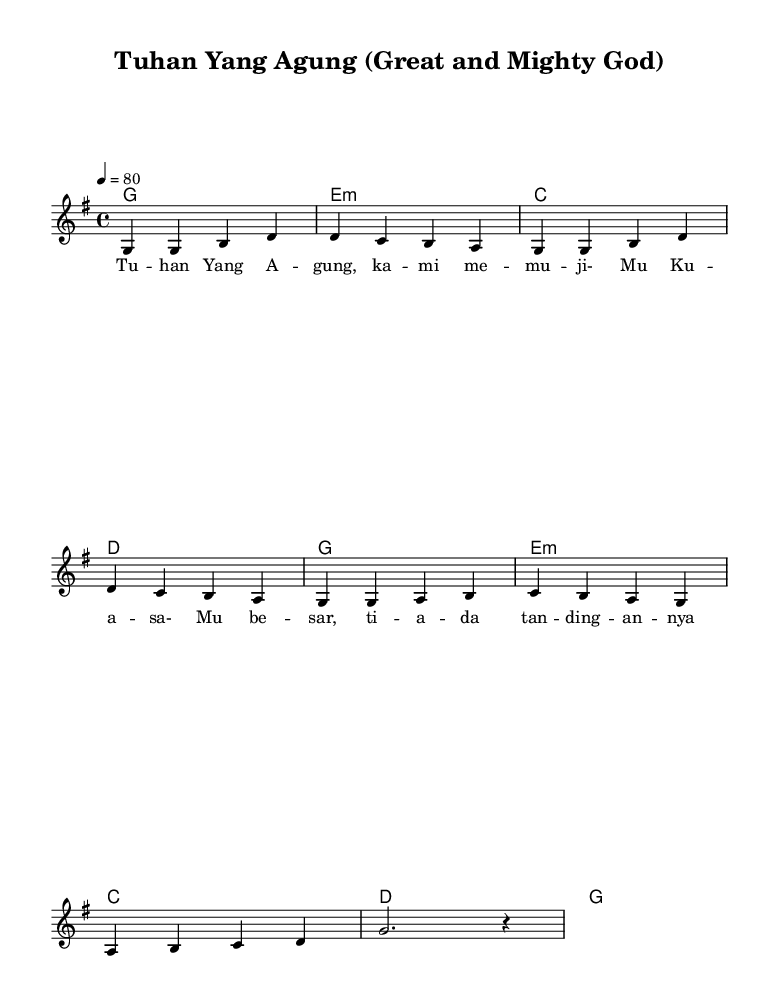What is the key signature of this music? The key signature is G major, which has one sharp (F#), identifiable by looking at the beginning of the staff.
Answer: G major What is the time signature of the piece? The time signature is 4/4, indicated at the beginning of the score. This means there are four beats in each measure.
Answer: 4/4 What is the tempo marking for the music? The tempo marking indicates a speed of 80 beats per minute, as seen at the beginning of the score.
Answer: 80 How many measures are in the melody? The melody consists of eight measures, which can be counted by looking at the bar lines that divide the music into segments.
Answer: 8 measures What is the tonic chord in this piece? The tonic chord is G major, as it is the chord built on the first degree of the G major scale, and it is the first chord listed in the harmonies section.
Answer: G major What is the lyrical theme of the first verse? The lyrical theme of the first verse expresses praise to God and the acknowledgment of His greatness, inferred from the song title and the lyrics provided.
Answer: Praise to God Which chord follows the D major chord in the harmonies section? The chord that follows the D major chord is G major, as shown in the chord sequence in the harmonies section where D is followed by G.
Answer: G major 